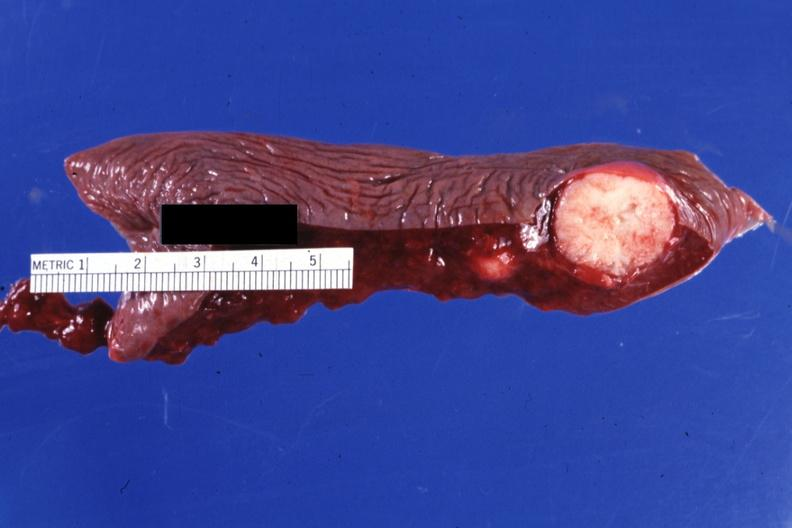s chronic ischemia present?
Answer the question using a single word or phrase. No 